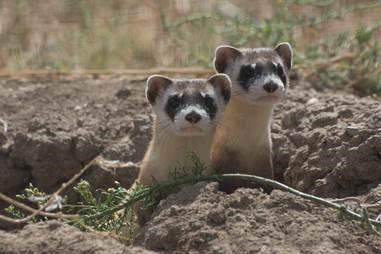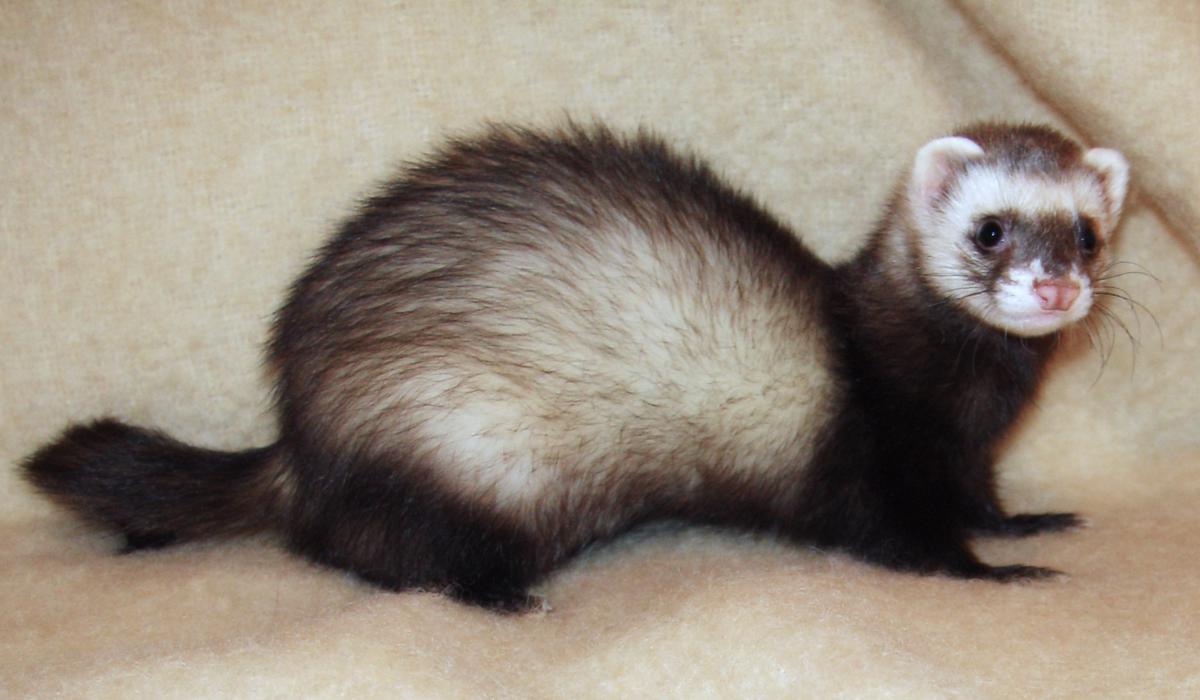The first image is the image on the left, the second image is the image on the right. Examine the images to the left and right. Is the description "Each image contains the same number of animals." accurate? Answer yes or no. No. 